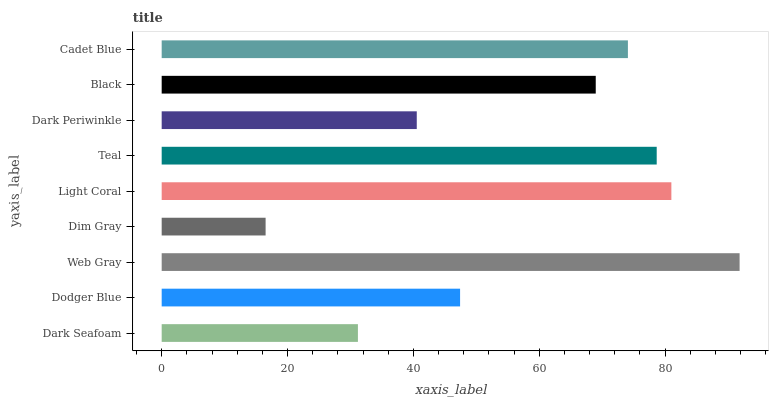Is Dim Gray the minimum?
Answer yes or no. Yes. Is Web Gray the maximum?
Answer yes or no. Yes. Is Dodger Blue the minimum?
Answer yes or no. No. Is Dodger Blue the maximum?
Answer yes or no. No. Is Dodger Blue greater than Dark Seafoam?
Answer yes or no. Yes. Is Dark Seafoam less than Dodger Blue?
Answer yes or no. Yes. Is Dark Seafoam greater than Dodger Blue?
Answer yes or no. No. Is Dodger Blue less than Dark Seafoam?
Answer yes or no. No. Is Black the high median?
Answer yes or no. Yes. Is Black the low median?
Answer yes or no. Yes. Is Dark Periwinkle the high median?
Answer yes or no. No. Is Dark Periwinkle the low median?
Answer yes or no. No. 